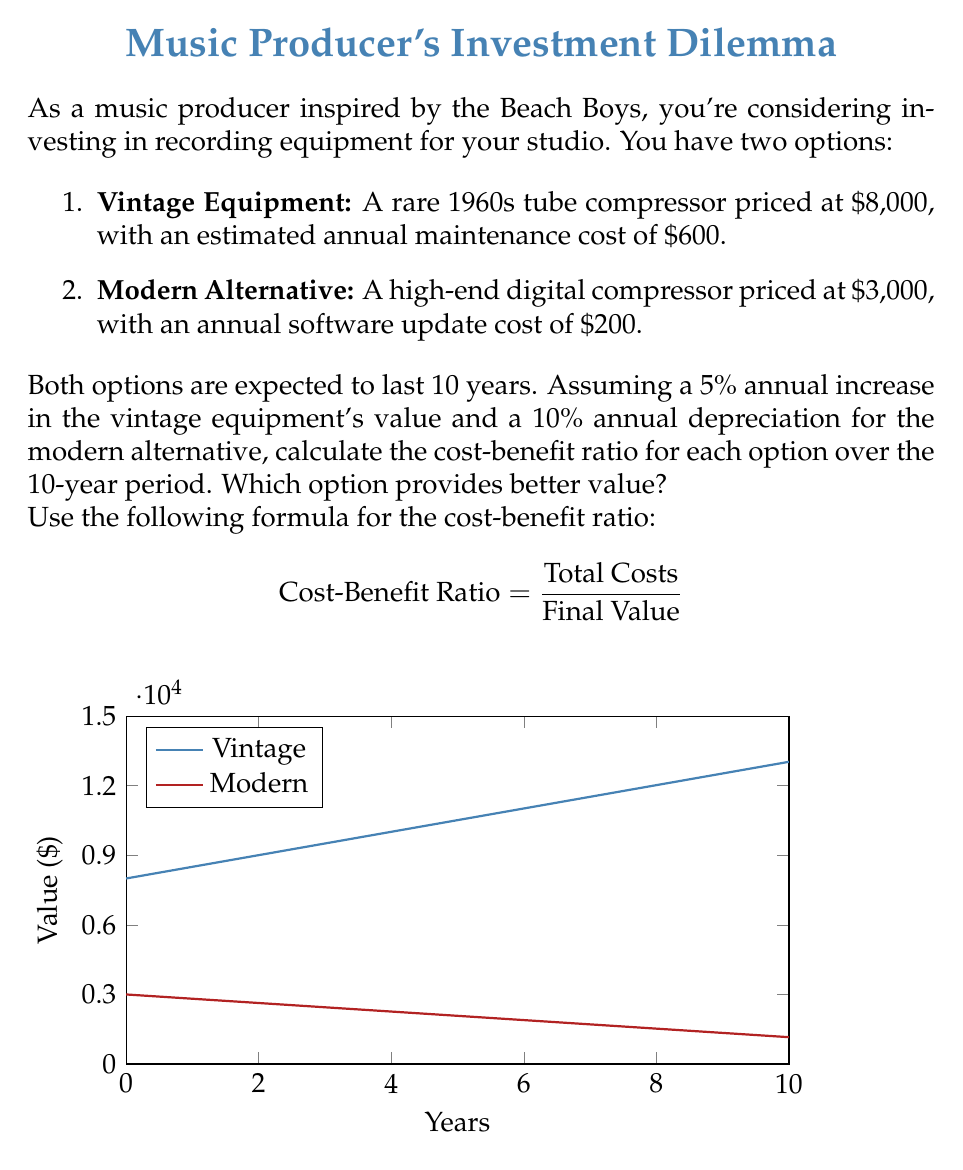What is the answer to this math problem? Let's calculate the cost-benefit ratio for each option:

1. Vintage Equipment:
   Initial cost: $8,000
   Annual maintenance: $600
   Total maintenance cost over 10 years: $600 × 10 = $6,000
   Total costs: $8,000 + $6,000 = $14,000
   
   Final value after 10 years with 5% annual increase:
   $8,000 × (1.05)^{10} ≈ $13,030.49
   
   Cost-Benefit Ratio:
   $$ \frac{14,000}{13,030.49} ≈ 1.07 $$

2. Modern Alternative:
   Initial cost: $3,000
   Annual software update: $200
   Total update cost over 10 years: $200 × 10 = $2,000
   Total costs: $3,000 + $2,000 = $5,000
   
   Final value after 10 years with 10% annual depreciation:
   $3,000 × (0.9)^{10} ≈ $1,159.48
   
   Cost-Benefit Ratio:
   $$ \frac{5,000}{1,159.48} ≈ 4.31 $$

The vintage equipment has a lower cost-benefit ratio (1.07 < 4.31), indicating it provides better value over the 10-year period. This is primarily due to its appreciation in value, which offsets the higher initial cost and maintenance expenses.
Answer: Vintage equipment provides better value with a cost-benefit ratio of 1.07 compared to 4.31 for the modern alternative. 